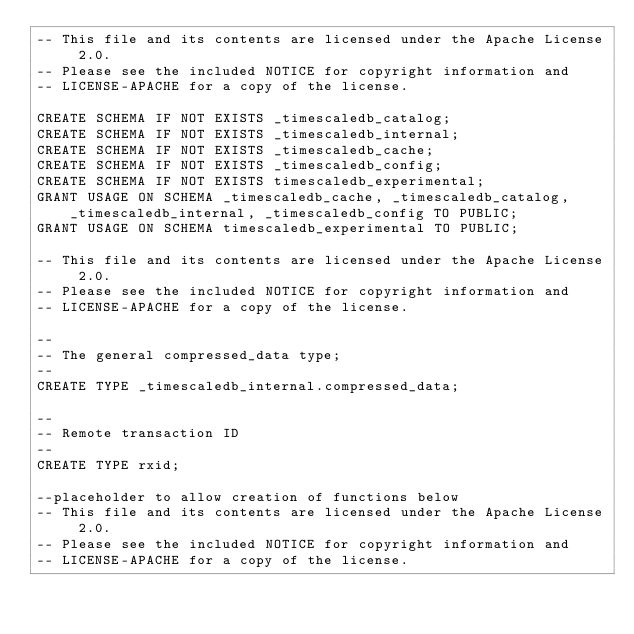<code> <loc_0><loc_0><loc_500><loc_500><_SQL_>-- This file and its contents are licensed under the Apache License 2.0.
-- Please see the included NOTICE for copyright information and
-- LICENSE-APACHE for a copy of the license.

CREATE SCHEMA IF NOT EXISTS _timescaledb_catalog;
CREATE SCHEMA IF NOT EXISTS _timescaledb_internal;
CREATE SCHEMA IF NOT EXISTS _timescaledb_cache;
CREATE SCHEMA IF NOT EXISTS _timescaledb_config;
CREATE SCHEMA IF NOT EXISTS timescaledb_experimental;
GRANT USAGE ON SCHEMA _timescaledb_cache, _timescaledb_catalog, _timescaledb_internal, _timescaledb_config TO PUBLIC;
GRANT USAGE ON SCHEMA timescaledb_experimental TO PUBLIC;

-- This file and its contents are licensed under the Apache License 2.0.
-- Please see the included NOTICE for copyright information and
-- LICENSE-APACHE for a copy of the license.

--
-- The general compressed_data type;
--
CREATE TYPE _timescaledb_internal.compressed_data;

--
-- Remote transaction ID
--
CREATE TYPE rxid;

--placeholder to allow creation of functions below
-- This file and its contents are licensed under the Apache License 2.0.
-- Please see the included NOTICE for copyright information and
-- LICENSE-APACHE for a copy of the license.

</code> 